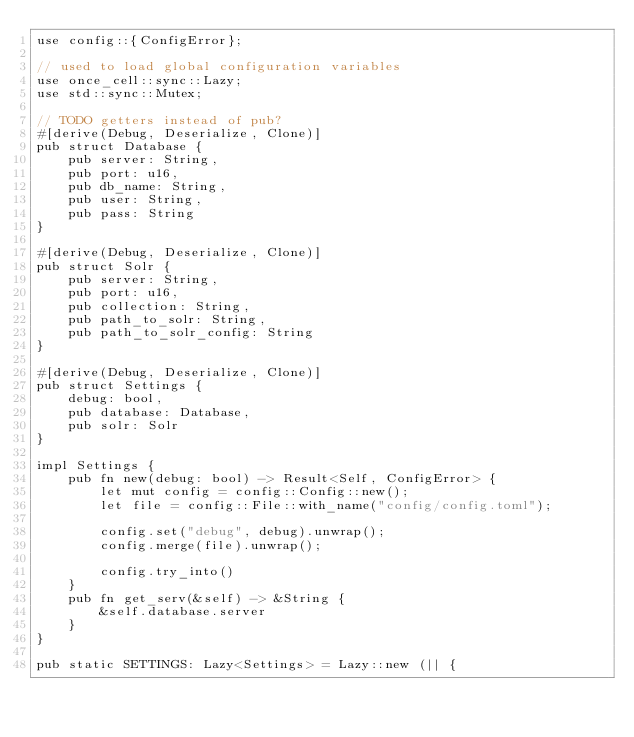<code> <loc_0><loc_0><loc_500><loc_500><_Rust_>use config::{ConfigError};

// used to load global configuration variables
use once_cell::sync::Lazy;
use std::sync::Mutex;

// TODO getters instead of pub?
#[derive(Debug, Deserialize, Clone)]
pub struct Database {
    pub server: String,
    pub port: u16,
    pub db_name: String,
    pub user: String,
    pub pass: String
}

#[derive(Debug, Deserialize, Clone)]
pub struct Solr {
    pub server: String,
    pub port: u16,
    pub collection: String,
    pub path_to_solr: String,
    pub path_to_solr_config: String
}

#[derive(Debug, Deserialize, Clone)]
pub struct Settings {
    debug: bool,
    pub database: Database,
    pub solr: Solr
}

impl Settings {
    pub fn new(debug: bool) -> Result<Self, ConfigError> {
        let mut config = config::Config::new();
        let file = config::File::with_name("config/config.toml");

        config.set("debug", debug).unwrap();
        config.merge(file).unwrap();

        config.try_into()
    }
    pub fn get_serv(&self) -> &String {
        &self.database.server
    }
}

pub static SETTINGS: Lazy<Settings> = Lazy::new (|| {</code> 